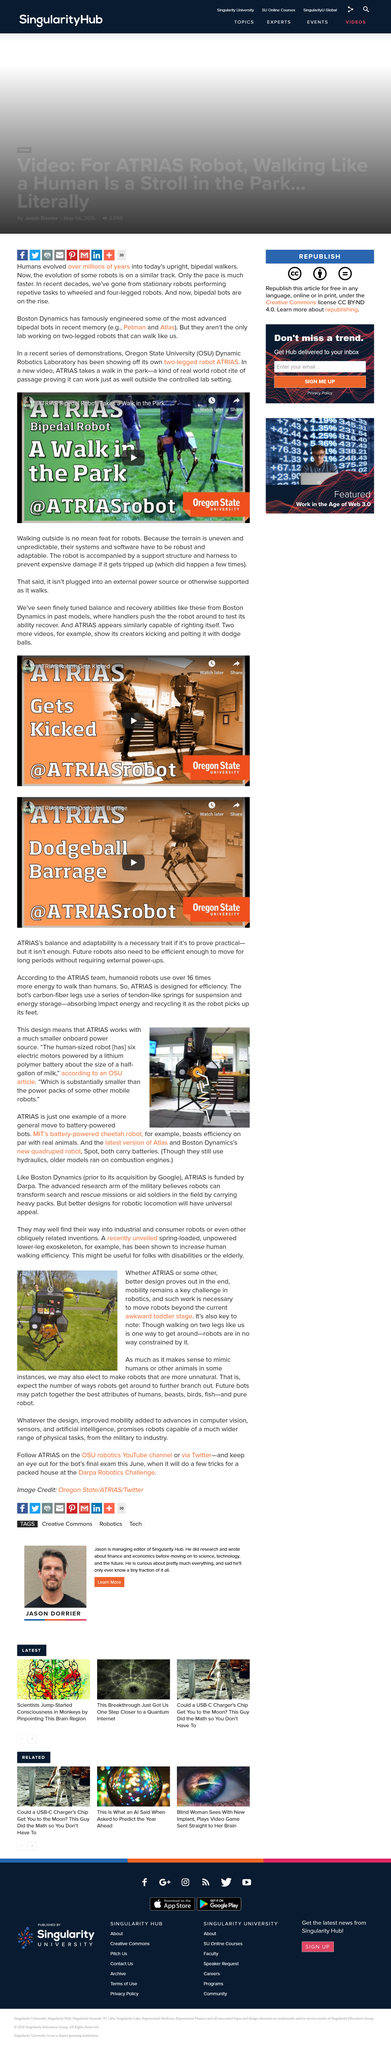Draw attention to some important aspects in this diagram. ATRIAS is an example of a more general move towards battery-powered bots, which are becoming increasingly popular in various industries. The fact is that mechanical devices, such as robots, are not limited to walking on two legs. In fact, they can be designed and built in numerous ways to accomplish tasks, navigate obstacles, and move about in a variety of ways. The ATRIAS system utilizes a much smaller power source compared to traditional drones, allowing for increased maneuverability and flexibility in flight. The article mentions a specific aquatic animal called fish. The ATRIAS is powered by an electric motor that is fueled by a lithium polymer battery, which is approximately the size of a half-gallon of milk. 